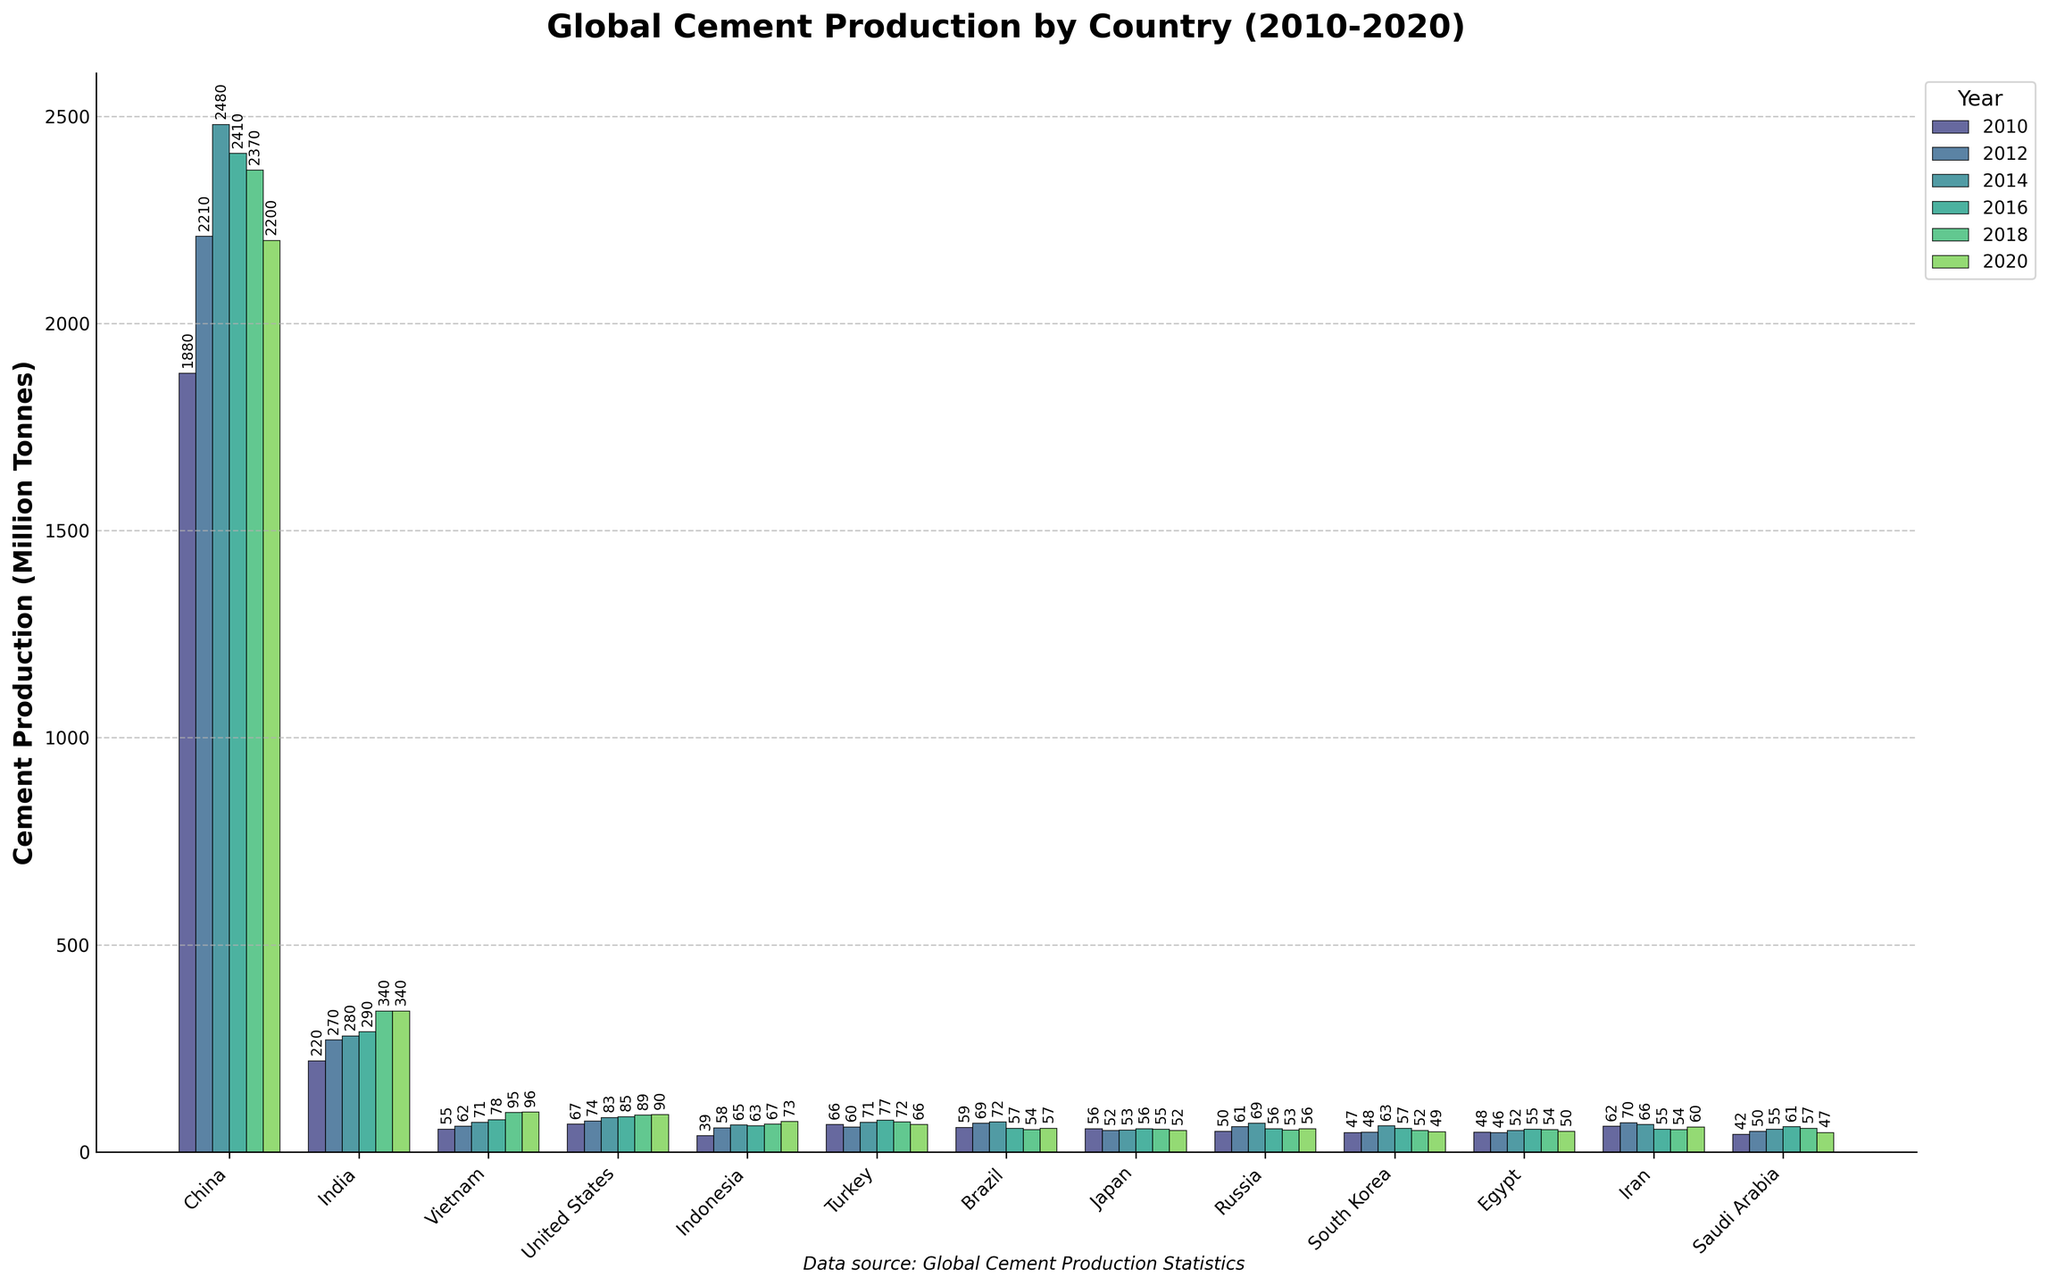what's the total cement production of India from 2010 to 2020? Sum the values of India's cement production for all the listed years: 220 + 270 + 280 + 290 + 340 + 340 = 1740
Answer: 1740 Which country showed the highest cement production in 2018? By visually inspecting the height of the bars for each country in 2018, China's bar is the tallest.
Answer: China What is the difference in cement production between China and the United States in 2020? Subtract the United States' cement production from China's in 2020: 2200 - 90 = 2110
Answer: 2110 Which country had the least cement production in 2010? By looking at the bars in 2010, Saudi Arabia has the shortest bar, indicating the least production.
Answer: Saudi Arabia How did cement production in Vietnam change from 2010 to 2020? Subtract the cement production in 2010 from that in 2020 for Vietnam: 96 - 55 = 41. Vietnam's cement production increased by 41 million tonnes.
Answer: Increased by 41 In which year did Turkey have the highest cement production? By inspecting Turkey's bars for all years, the bar in 2016 is the tallest, indicating the highest production in that year.
Answer: 2016 What is the average cement production of Egypt from 2010 to 2020? Sum the values and divide by the number of years: (48 + 46 + 52 + 55 + 54 + 50) / 6 ≈ 50.83
Answer: 50.83 How much more cement did Indonesia produce in 2020 compared to 2010? Subtract Indonesia's cement production in 2010 from that in 2020: 73 - 39 = 34
Answer: 34 Which two countries had nearly equal cement production in 2016? By comparing the heights of bars in 2016, both the US and Indonesia have nearly equal heights, around 85 and 63 respectively.
Answer: United States and Indonesia 